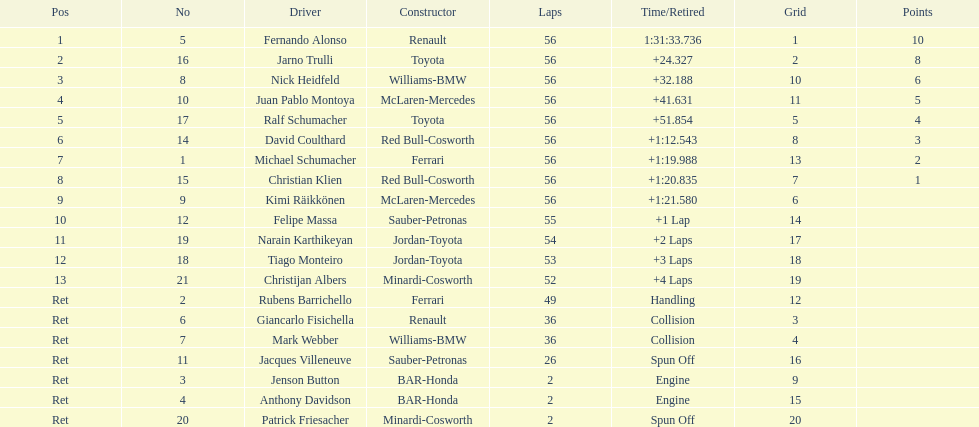Who finished before nick heidfeld? Jarno Trulli. 